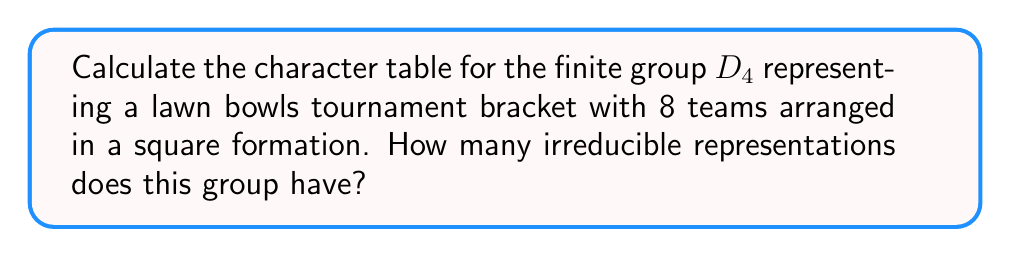Teach me how to tackle this problem. Let's approach this step-by-step:

1) First, we need to understand that $D_4$ is the dihedral group of order 8, which represents the symmetries of a square. This fits well with a lawn bowls tournament bracket for 8 teams.

2) The elements of $D_4$ are:
   - e (identity)
   - $r$, $r^2$, $r^3$ (rotations by 90°, 180°, 270°)
   - $s$, $sr$, $sr^2$, $sr^3$ (reflections)

3) The conjugacy classes of $D_4$ are:
   {e}, {$r^2$}, {$r$, $r^3$}, {$s$, $sr^2$}, {$sr$, $sr^3$}

4) The number of irreducible representations is equal to the number of conjugacy classes, which is 5.

5) We know that the sum of the squares of the dimensions of the irreducible representations must equal the order of the group (8). The only way to do this with 5 representations is 1, 1, 1, 1, 2.

6) Now, let's construct the character table:

   $$\begin{array}{c|ccccc}
      D_4 & \{e\} & \{r^2\} & \{r,r^3\} & \{s,sr^2\} & \{sr,sr^3\} \\
      \hline
      \chi_1 & 1 & 1 & 1 & 1 & 1 \\
      \chi_2 & 1 & 1 & 1 & -1 & -1 \\
      \chi_3 & 1 & 1 & -1 & 1 & -1 \\
      \chi_4 & 1 & 1 & -1 & -1 & 1 \\
      \chi_5 & 2 & -2 & 0 & 0 & 0
   \end{array}$$

7) $\chi_1$ is the trivial representation.
   $\chi_2$, $\chi_3$, and $\chi_4$ are one-dimensional representations.
   $\chi_5$ is the two-dimensional representation.

Therefore, the group $D_4$ representing the lawn bowls tournament bracket has 5 irreducible representations.
Answer: 5 irreducible representations 